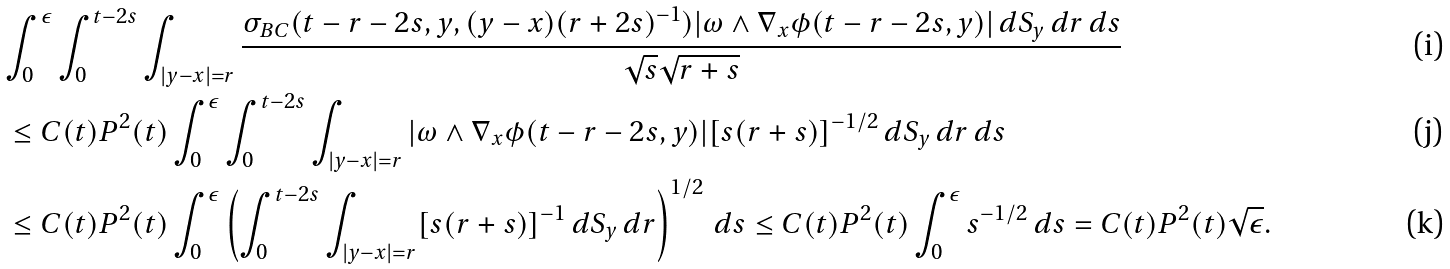<formula> <loc_0><loc_0><loc_500><loc_500>& \int ^ { \epsilon } _ { 0 } \int ^ { t - 2 s } _ { 0 } \int _ { | y - x | = r } \frac { \sigma _ { B C } ( t - r - 2 s , y , ( y - x ) ( r + 2 s ) ^ { - 1 } ) | \omega \wedge \nabla _ { x } \phi ( t - r - 2 s , y ) | \, d S _ { y } \, d r \, d s } { \sqrt { s } \sqrt { r + s } } \\ & \, \leq C ( t ) P ^ { 2 } ( t ) \int ^ { \epsilon } _ { 0 } \int ^ { t - 2 s } _ { 0 } \int _ { | y - x | = r } | \omega \wedge \nabla _ { x } \phi ( t - r - 2 s , y ) | [ s ( r + s ) ] ^ { - 1 / 2 } \, d S _ { y } \, d r \, d s \\ & \, \leq C ( t ) P ^ { 2 } ( t ) \int ^ { \epsilon } _ { 0 } \left ( \int ^ { t - 2 s } _ { 0 } \int _ { | y - x | = r } [ s ( r + s ) ] ^ { - 1 } \, d S _ { y } \, d r \right ) ^ { 1 / 2 } \, d s \leq C ( t ) P ^ { 2 } ( t ) \int ^ { \epsilon } _ { 0 } s ^ { - 1 / 2 } \, d s = C ( t ) P ^ { 2 } ( t ) \sqrt { \epsilon } .</formula> 